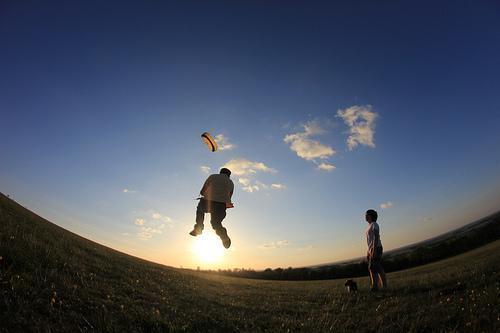How many people are in the photo?
Give a very brief answer. 2. 